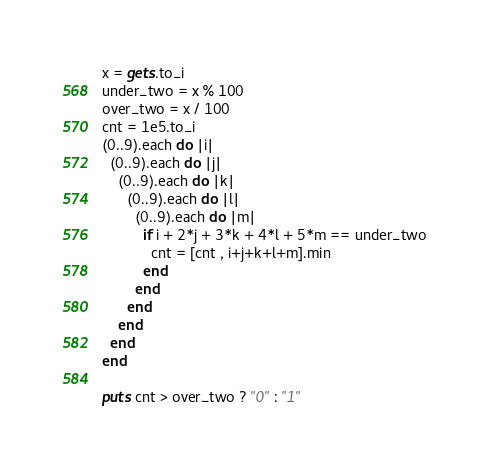<code> <loc_0><loc_0><loc_500><loc_500><_Ruby_>x = gets.to_i
under_two = x % 100
over_two = x / 100
cnt = 1e5.to_i
(0..9).each do |i|
  (0..9).each do |j|
    (0..9).each do |k|
      (0..9).each do |l|
        (0..9).each do |m|
          if i + 2*j + 3*k + 4*l + 5*m == under_two
            cnt = [cnt , i+j+k+l+m].min
          end
        end
      end
    end
  end
end

puts cnt > over_two ? "0" : "1"</code> 